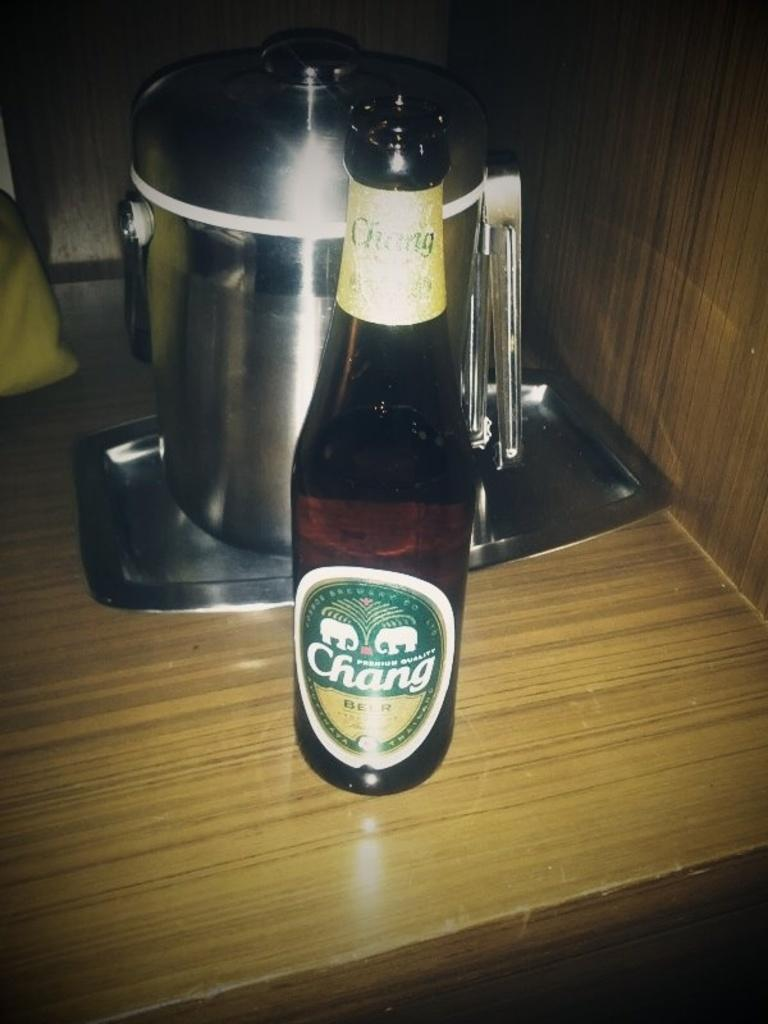<image>
Give a short and clear explanation of the subsequent image. A bottle of Chang beer stands on a tan desk in front of a pot. 